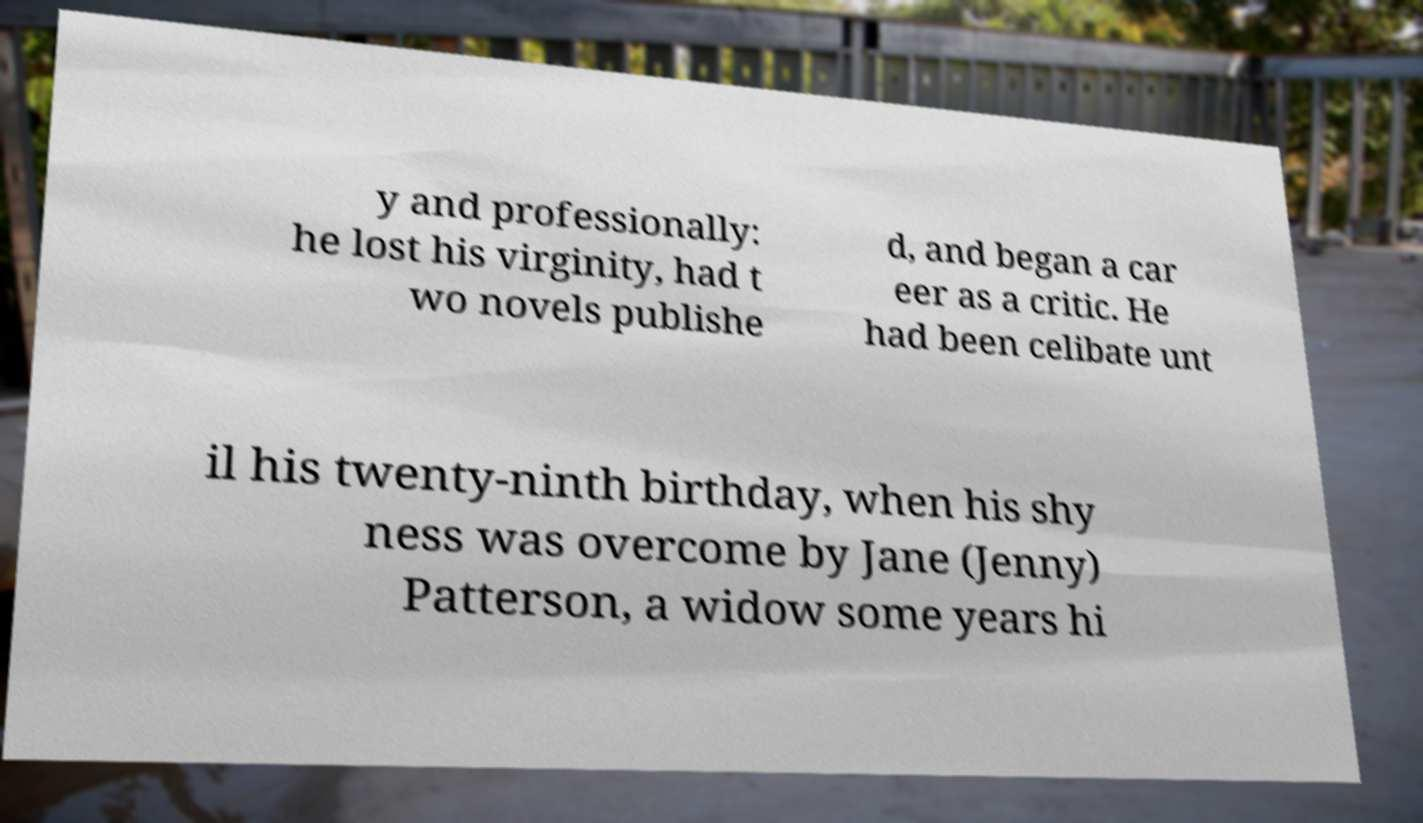Can you read and provide the text displayed in the image?This photo seems to have some interesting text. Can you extract and type it out for me? y and professionally: he lost his virginity, had t wo novels publishe d, and began a car eer as a critic. He had been celibate unt il his twenty-ninth birthday, when his shy ness was overcome by Jane (Jenny) Patterson, a widow some years hi 